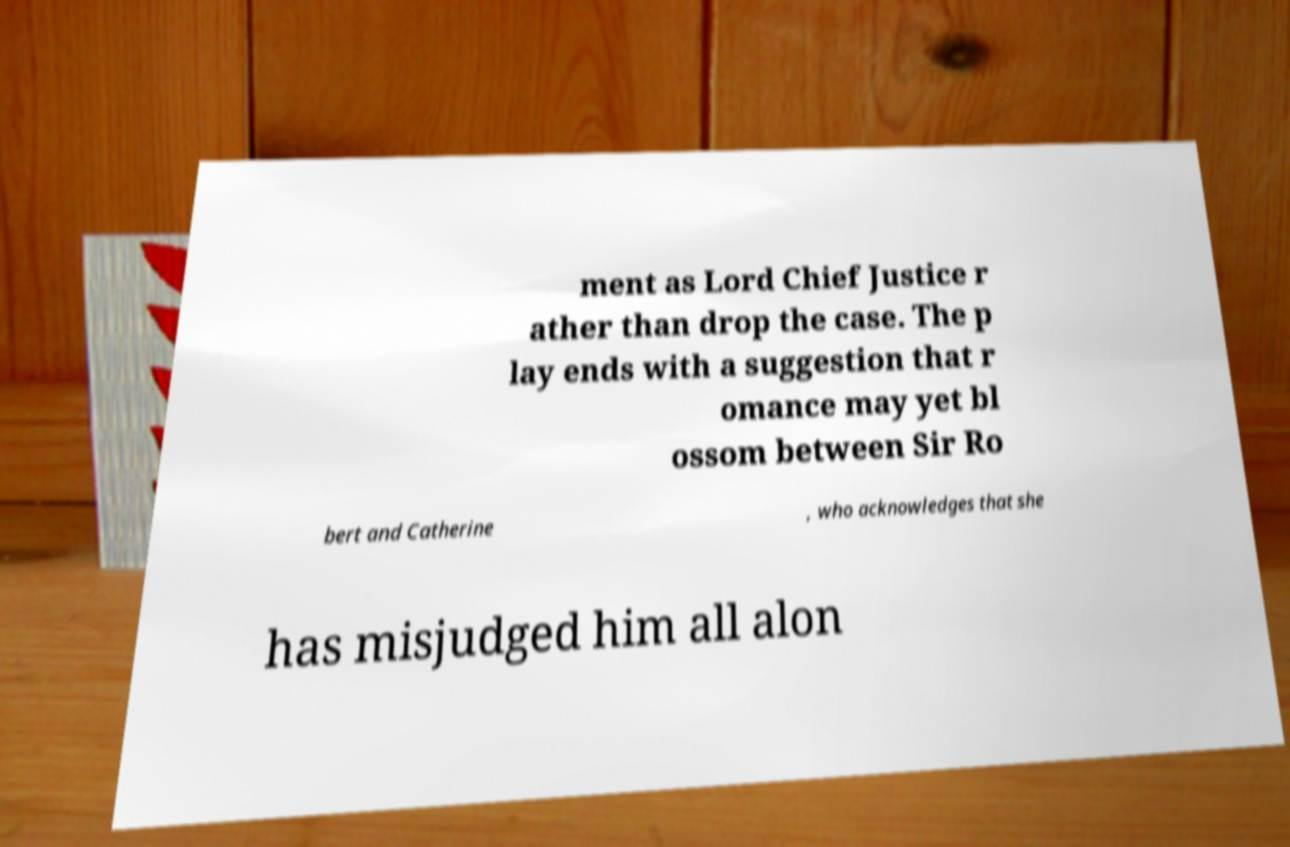For documentation purposes, I need the text within this image transcribed. Could you provide that? ment as Lord Chief Justice r ather than drop the case. The p lay ends with a suggestion that r omance may yet bl ossom between Sir Ro bert and Catherine , who acknowledges that she has misjudged him all alon 